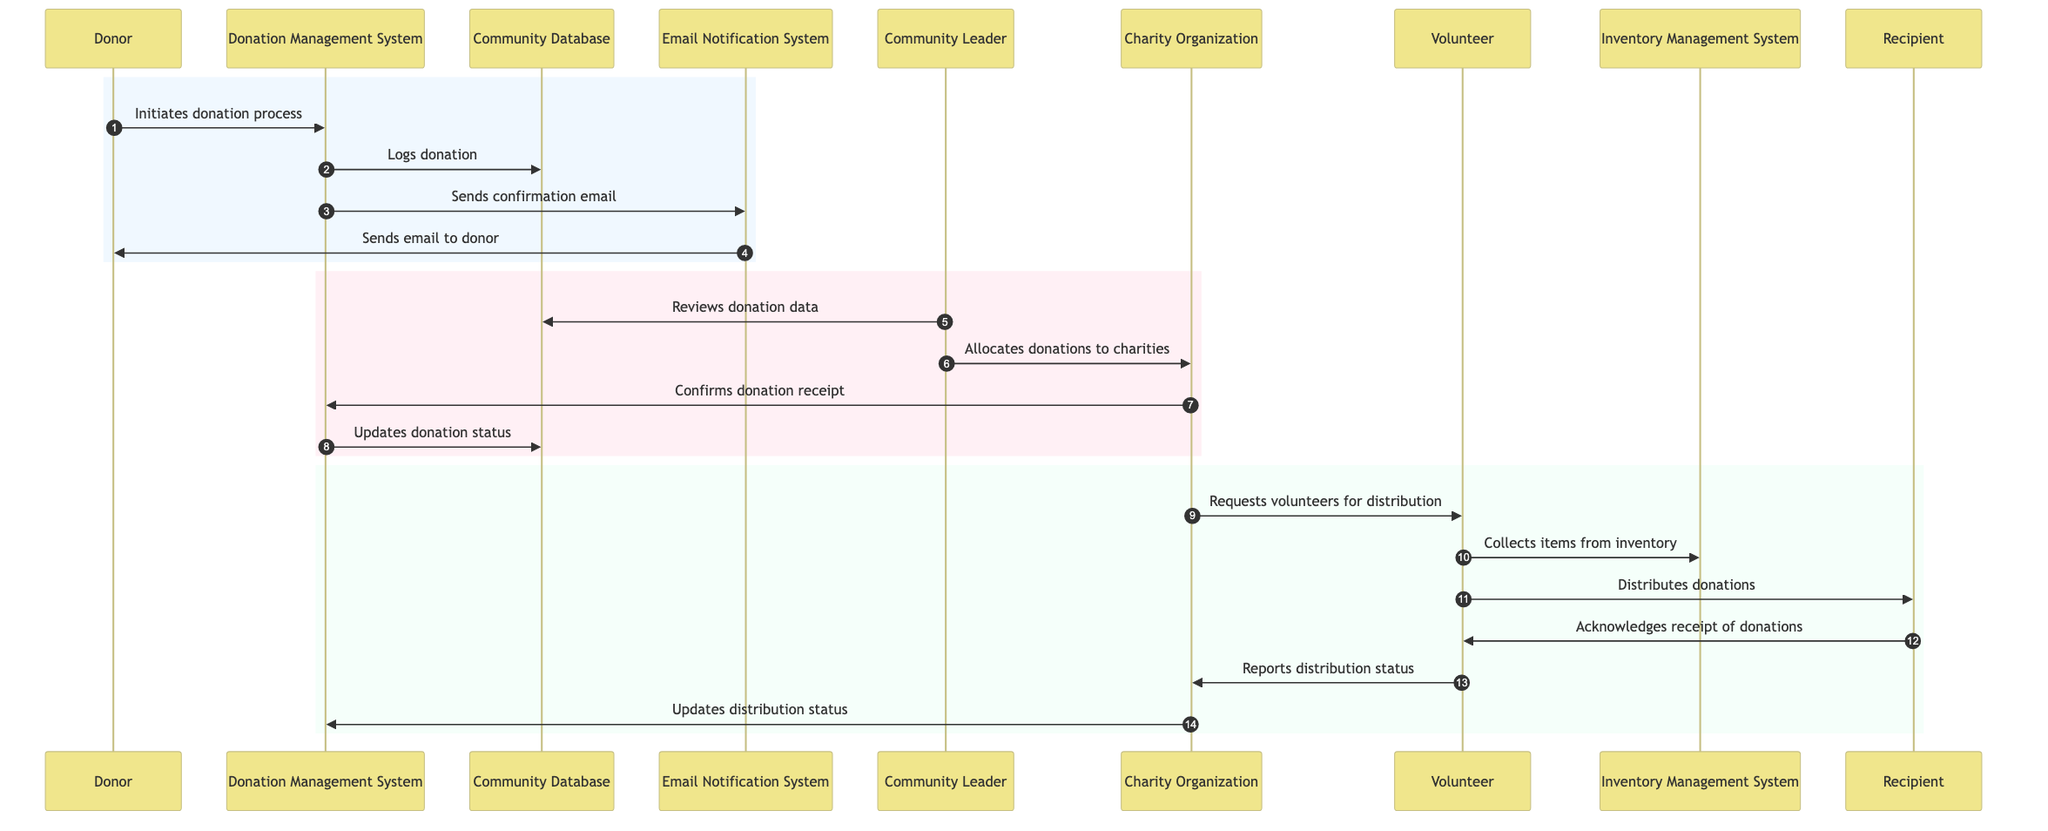What is the first action taken in the donation process? The first action is initiated by the Donor who starts the donation process. This is represented by the arrow from Donor to Donation Management System labeled "Initiates donation process".
Answer: Initiates donation process How many actors are involved in the workflow? The workflow includes five distinct actors: Donor, Community Leader, Charity Organization, Volunteer, and Recipient. This counts the unique participants labeled in the sequence diagram.
Answer: Five What does the Community Leader do after reviewing donation data? After reviewing the donation data, the Community Leader allocates donations to charities as depicted by the arrow leading from the Community Leader to Charity Organization labeled "Allocates donations to charities".
Answer: Allocates donations to charities Which actor is responsible for sending the confirmation email? The Donation Management System is responsible for sending the confirmation email as it does this action to the Email Notification System which then sends the email to the Donor.
Answer: Donation Management System What happens after the Charity Organization requests volunteers for distribution? After the Charity Organization requests volunteers for distribution, the Volunteer collects items from the inventory as indicated by the next arrow from Volunteer to Inventory Management System labeled "Collects items from inventory".
Answer: Collects items from inventory What type of notification does the Email Notification System send? The Email Notification System sends a confirmation email to the donor as indicated by the arrow from Email Notification System to Donor labeled "Sends email to donor".
Answer: Sends email to donor How does the process update when the Charity Organization confirms donation receipt? The process updates the donation status in the Community Database following the confirmation of receipt by the Charity Organization. This flow is indicated by the arrow from Charity Organization to Donation Management System and then from Donation Management System to Community Database.
Answer: Updates donation status Who acknowledges the receipt of donations? The Recipient acknowledges the receipt of donations to the Volunteer, as represented by the arrow from Recipient to Volunteer labeled "Acknowledges receipt of donations".
Answer: Recipient 